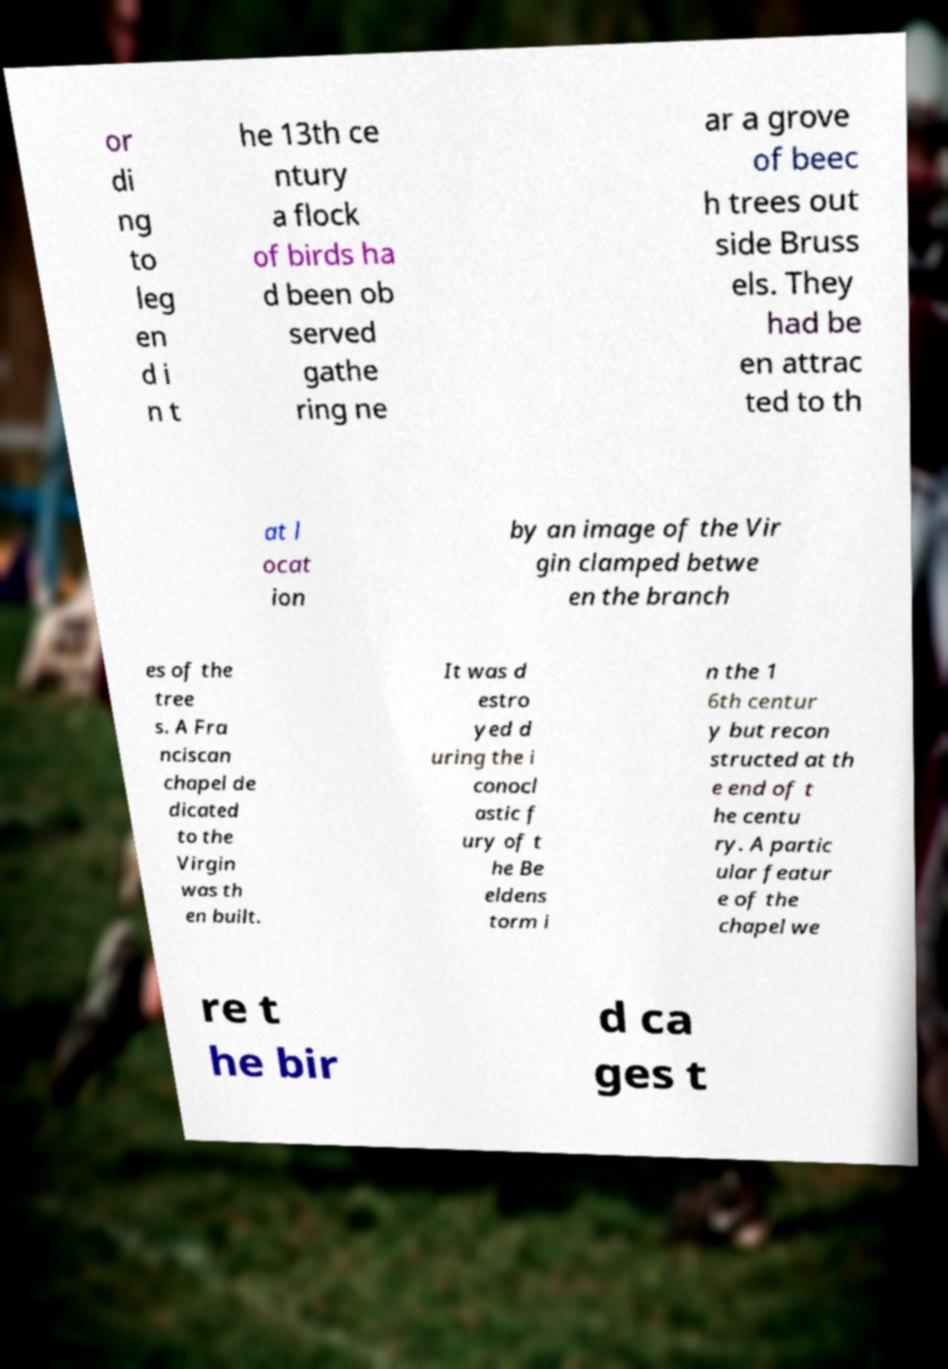For documentation purposes, I need the text within this image transcribed. Could you provide that? or di ng to leg en d i n t he 13th ce ntury a flock of birds ha d been ob served gathe ring ne ar a grove of beec h trees out side Bruss els. They had be en attrac ted to th at l ocat ion by an image of the Vir gin clamped betwe en the branch es of the tree s. A Fra nciscan chapel de dicated to the Virgin was th en built. It was d estro yed d uring the i conocl astic f ury of t he Be eldens torm i n the 1 6th centur y but recon structed at th e end of t he centu ry. A partic ular featur e of the chapel we re t he bir d ca ges t 